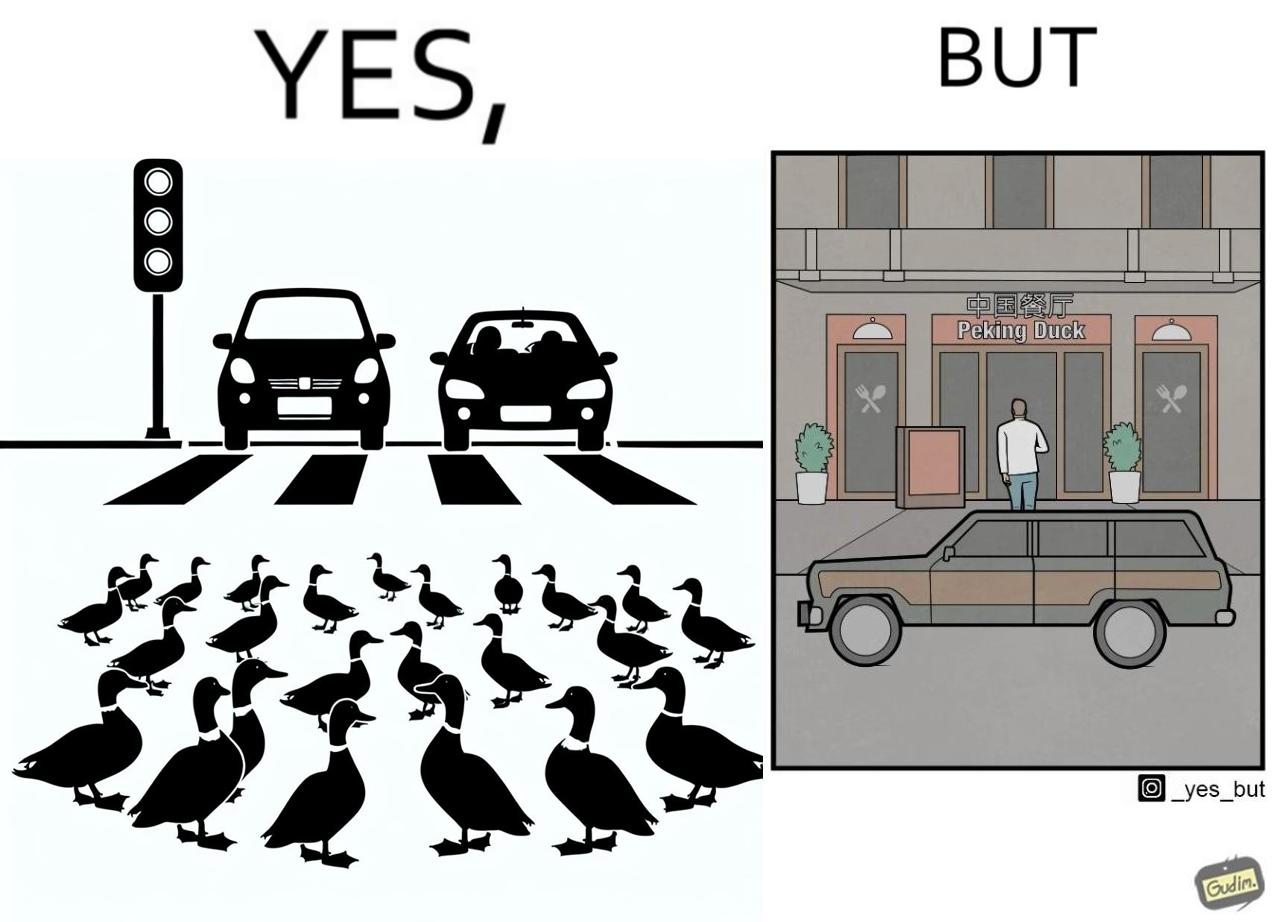Provide a description of this image. The images are ironic since they show how a man supposedly cares for ducks since he stops his vehicle to give way to queue of ducks allowing them to safely cross a road but on the other hand he goes to a peking duck shop to buy and eat similar ducks after having them killed 